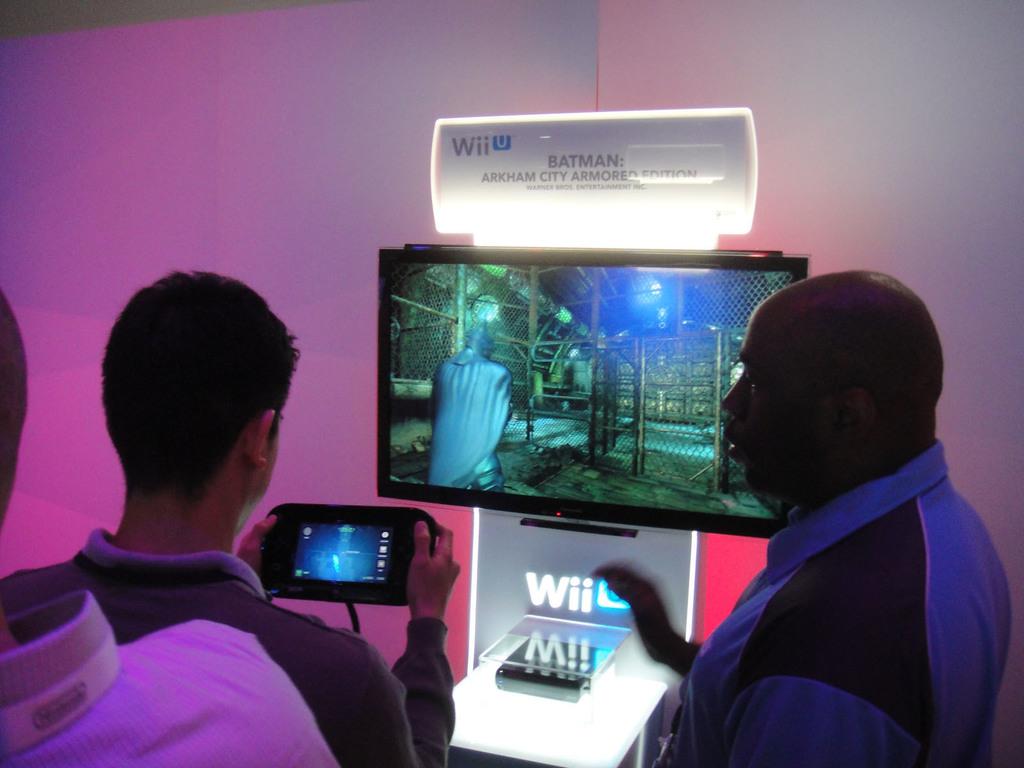What gaming system is displayed here?
Offer a very short reply. Wii u. What game are they playing?
Your response must be concise. Batman. 